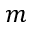<formula> <loc_0><loc_0><loc_500><loc_500>m</formula> 